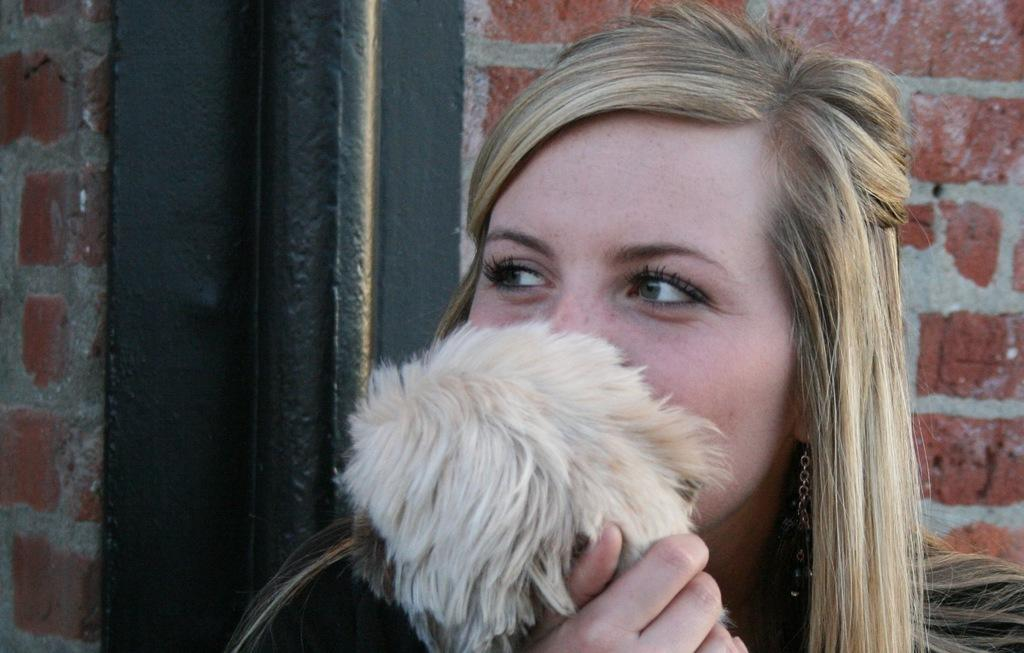Who is the main subject in the image? There is a woman in the image. What is the woman doing in the image? The woman is posing to the camera. What type of apparatus is the woman using to increase her height in the image? There is no apparatus present in the image, and the woman is not trying to increase her height. 